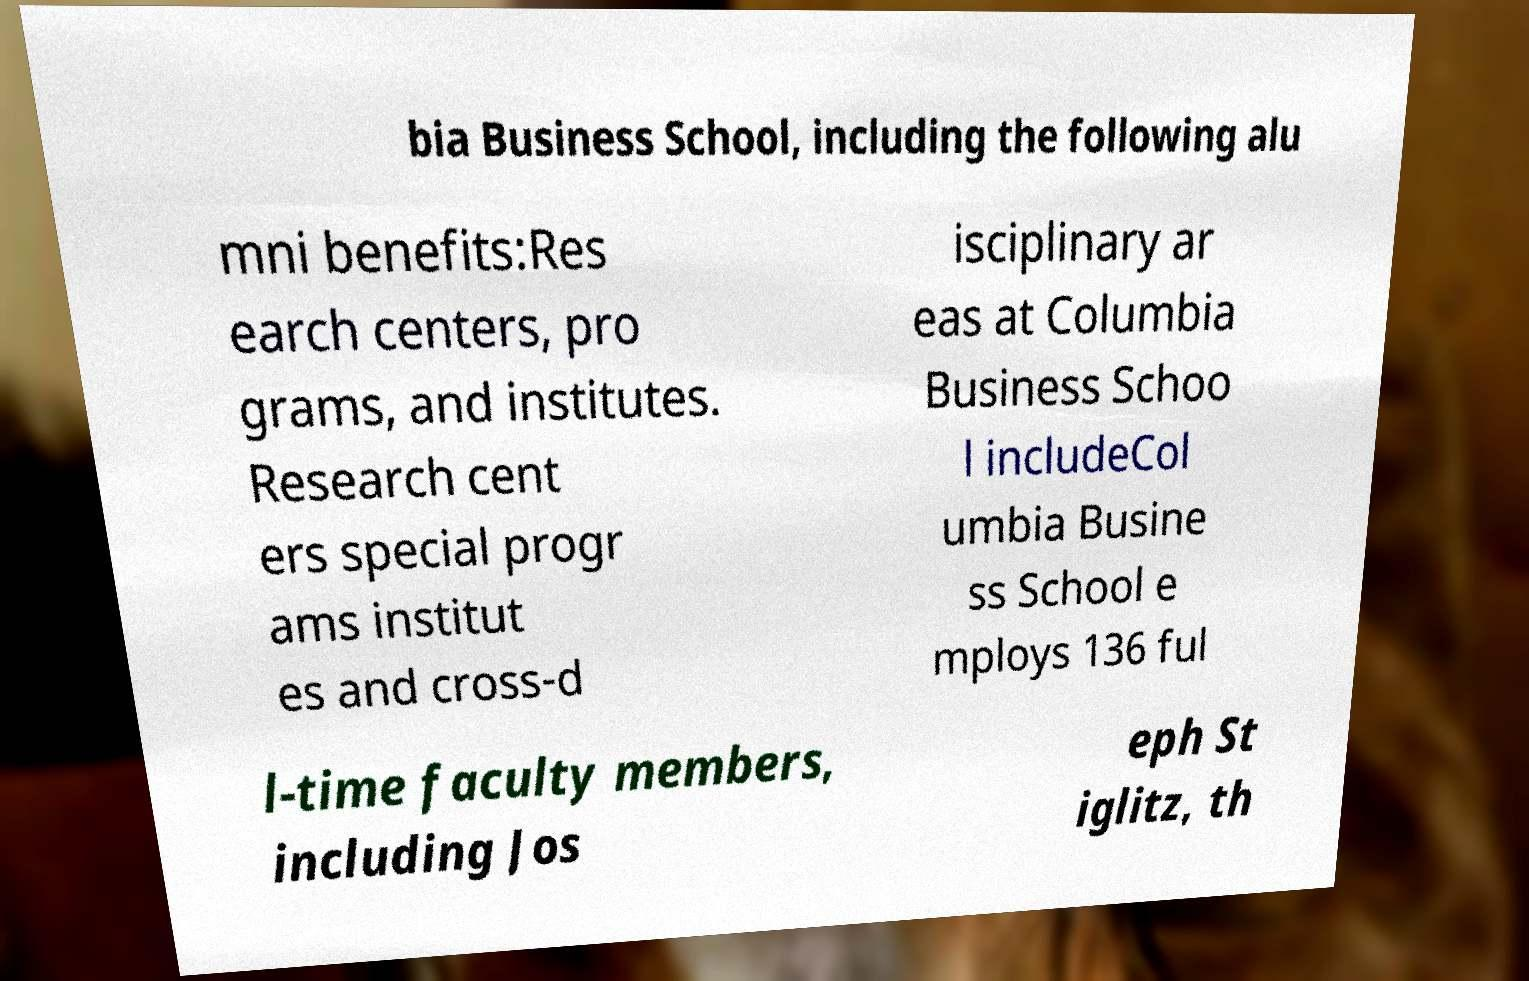Can you accurately transcribe the text from the provided image for me? bia Business School, including the following alu mni benefits:Res earch centers, pro grams, and institutes. Research cent ers special progr ams institut es and cross-d isciplinary ar eas at Columbia Business Schoo l includeCol umbia Busine ss School e mploys 136 ful l-time faculty members, including Jos eph St iglitz, th 